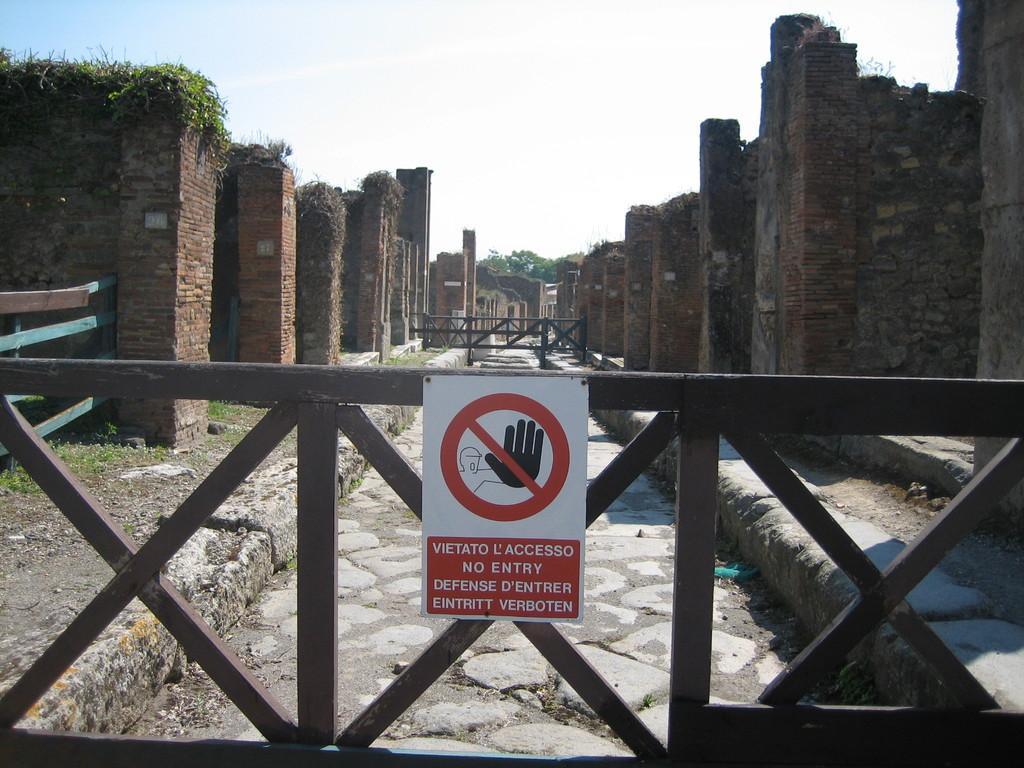Please provide a concise description of this image. In front of the picture, we see the railing and a board in white and red color with some text written on it. Behind that, we see the pavement. On either side of the picture, we see the pillars and the walls, which are made up of brown colored bricks. On the left side, we see the shrubs and the railing. In the middle, we see the railing. There are trees and the buildings in the background. At the top, we see the sky. 